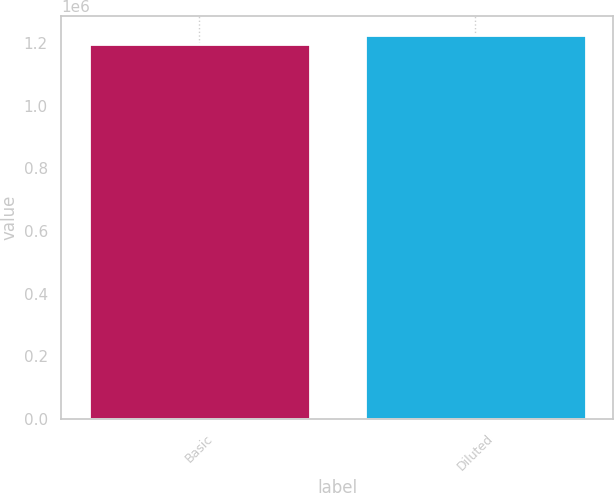<chart> <loc_0><loc_0><loc_500><loc_500><bar_chart><fcel>Basic<fcel>Diluted<nl><fcel>1.19624e+06<fcel>1.22389e+06<nl></chart> 